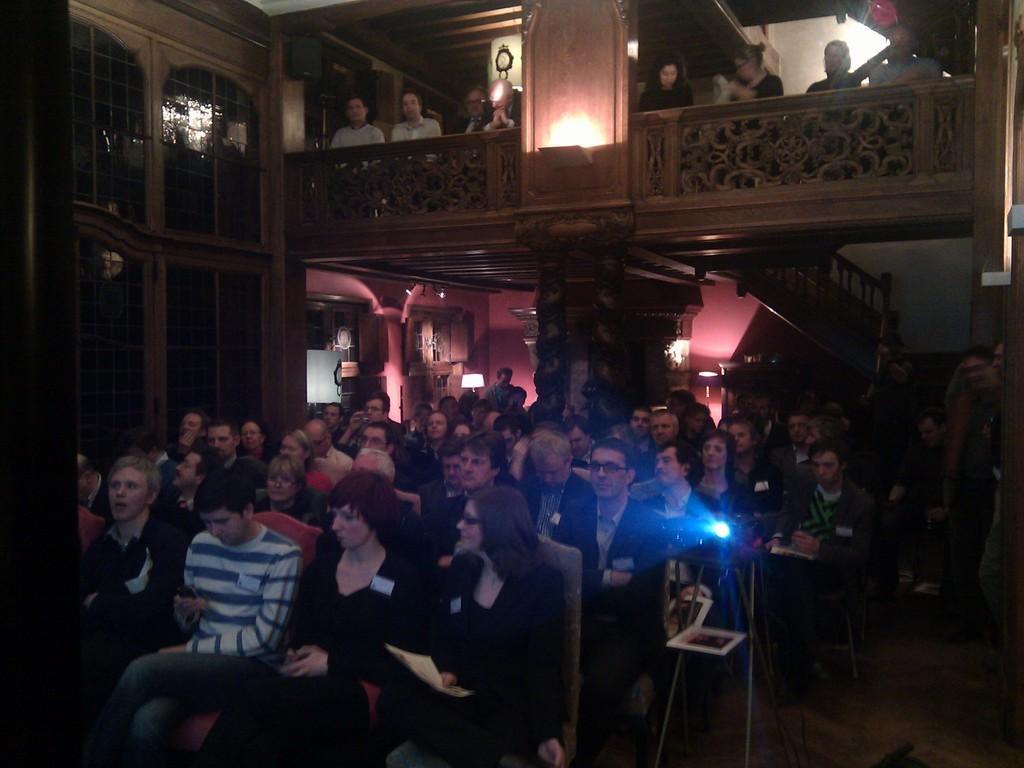How would you summarize this image in a sentence or two? In this picture there is a group of men and women sitting in the hall and watching something. In the front side we can see a projector lens. Behind on the top there is a balcony with some persons standing and looking. On the left corner there is a glass window. 